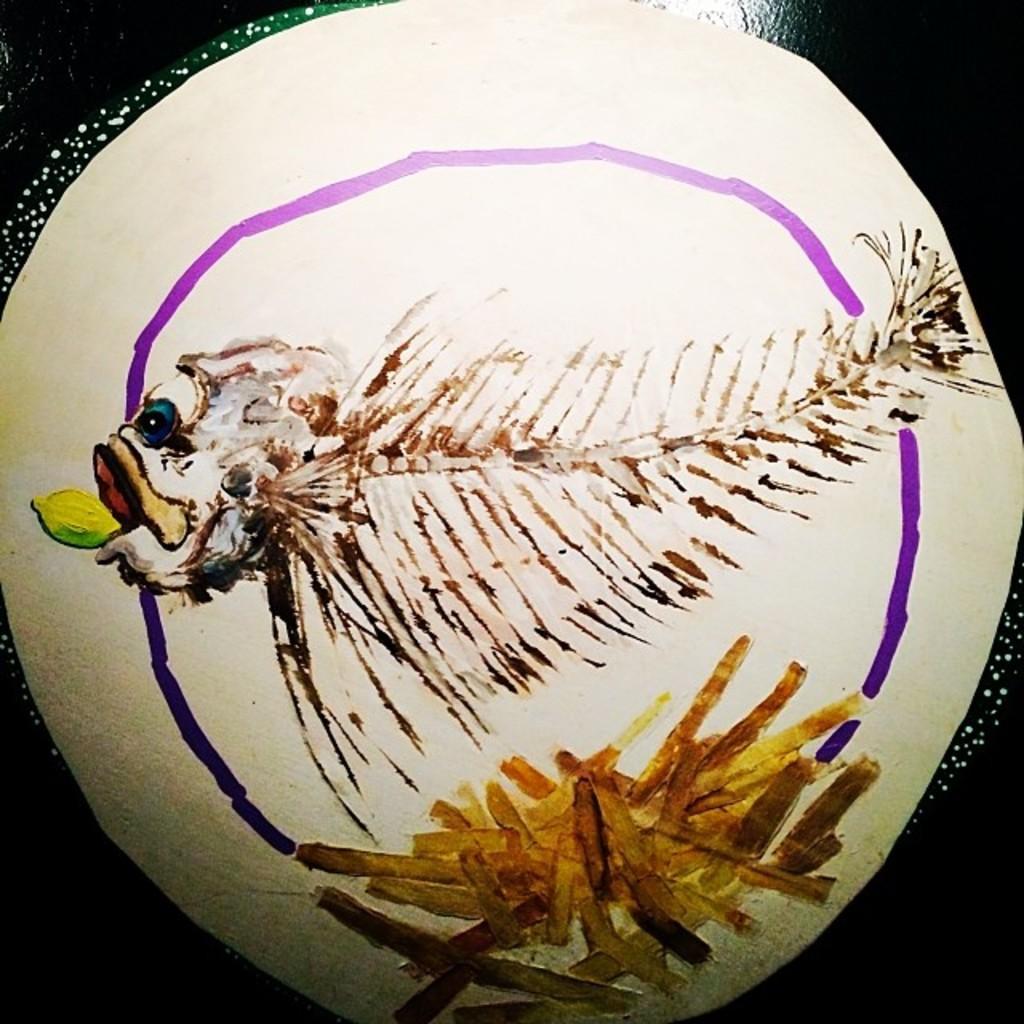Can you describe this image briefly? This is an object. 